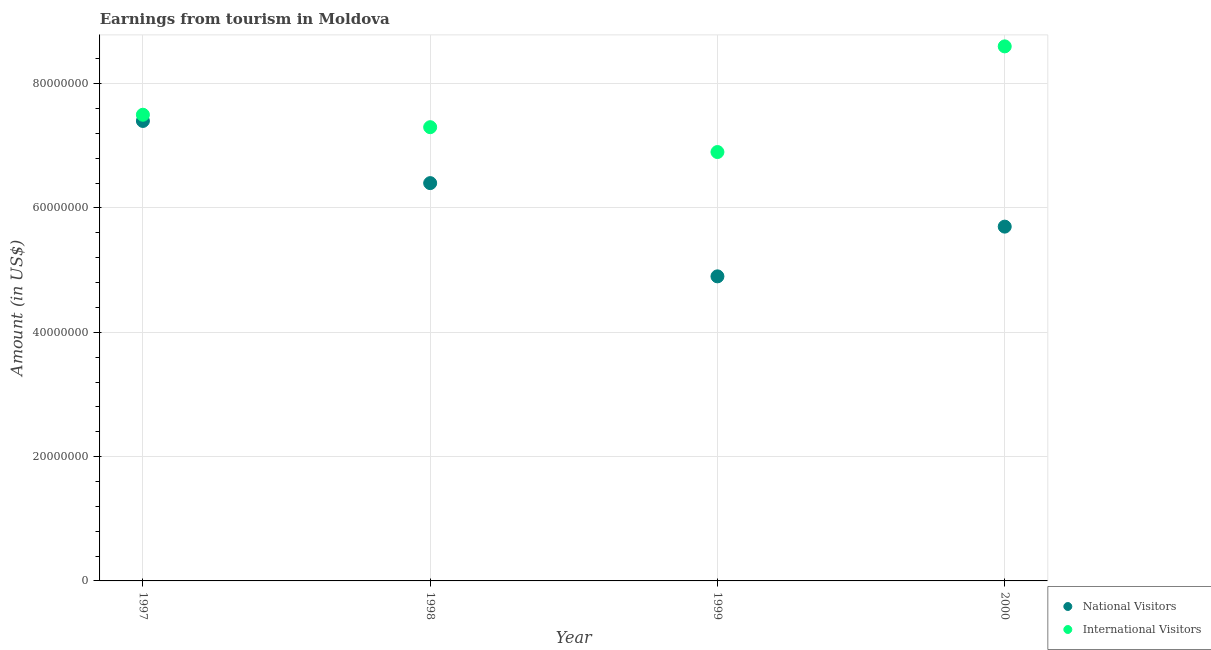What is the amount earned from international visitors in 1999?
Give a very brief answer. 6.90e+07. Across all years, what is the maximum amount earned from national visitors?
Make the answer very short. 7.40e+07. Across all years, what is the minimum amount earned from international visitors?
Your answer should be compact. 6.90e+07. What is the total amount earned from national visitors in the graph?
Make the answer very short. 2.44e+08. What is the difference between the amount earned from international visitors in 1998 and that in 1999?
Your answer should be compact. 4.00e+06. What is the difference between the amount earned from national visitors in 1997 and the amount earned from international visitors in 2000?
Offer a terse response. -1.20e+07. What is the average amount earned from national visitors per year?
Give a very brief answer. 6.10e+07. In the year 1999, what is the difference between the amount earned from international visitors and amount earned from national visitors?
Keep it short and to the point. 2.00e+07. In how many years, is the amount earned from national visitors greater than 80000000 US$?
Keep it short and to the point. 0. What is the ratio of the amount earned from international visitors in 1999 to that in 2000?
Make the answer very short. 0.8. What is the difference between the highest and the second highest amount earned from international visitors?
Offer a very short reply. 1.10e+07. What is the difference between the highest and the lowest amount earned from national visitors?
Offer a very short reply. 2.50e+07. Is the sum of the amount earned from national visitors in 1997 and 1998 greater than the maximum amount earned from international visitors across all years?
Keep it short and to the point. Yes. Does the amount earned from national visitors monotonically increase over the years?
Your answer should be very brief. No. Is the amount earned from national visitors strictly less than the amount earned from international visitors over the years?
Keep it short and to the point. Yes. How many dotlines are there?
Your response must be concise. 2. How many years are there in the graph?
Provide a succinct answer. 4. What is the difference between two consecutive major ticks on the Y-axis?
Make the answer very short. 2.00e+07. Are the values on the major ticks of Y-axis written in scientific E-notation?
Your answer should be very brief. No. Does the graph contain grids?
Provide a succinct answer. Yes. How many legend labels are there?
Offer a terse response. 2. What is the title of the graph?
Provide a short and direct response. Earnings from tourism in Moldova. Does "IMF nonconcessional" appear as one of the legend labels in the graph?
Keep it short and to the point. No. What is the label or title of the X-axis?
Your response must be concise. Year. What is the Amount (in US$) of National Visitors in 1997?
Keep it short and to the point. 7.40e+07. What is the Amount (in US$) of International Visitors in 1997?
Provide a short and direct response. 7.50e+07. What is the Amount (in US$) in National Visitors in 1998?
Provide a succinct answer. 6.40e+07. What is the Amount (in US$) of International Visitors in 1998?
Your response must be concise. 7.30e+07. What is the Amount (in US$) in National Visitors in 1999?
Ensure brevity in your answer.  4.90e+07. What is the Amount (in US$) in International Visitors in 1999?
Your answer should be compact. 6.90e+07. What is the Amount (in US$) in National Visitors in 2000?
Your answer should be very brief. 5.70e+07. What is the Amount (in US$) of International Visitors in 2000?
Offer a terse response. 8.60e+07. Across all years, what is the maximum Amount (in US$) in National Visitors?
Offer a terse response. 7.40e+07. Across all years, what is the maximum Amount (in US$) of International Visitors?
Provide a succinct answer. 8.60e+07. Across all years, what is the minimum Amount (in US$) in National Visitors?
Your answer should be compact. 4.90e+07. Across all years, what is the minimum Amount (in US$) in International Visitors?
Offer a very short reply. 6.90e+07. What is the total Amount (in US$) in National Visitors in the graph?
Offer a very short reply. 2.44e+08. What is the total Amount (in US$) of International Visitors in the graph?
Offer a very short reply. 3.03e+08. What is the difference between the Amount (in US$) in National Visitors in 1997 and that in 1998?
Offer a terse response. 1.00e+07. What is the difference between the Amount (in US$) in National Visitors in 1997 and that in 1999?
Provide a succinct answer. 2.50e+07. What is the difference between the Amount (in US$) of National Visitors in 1997 and that in 2000?
Make the answer very short. 1.70e+07. What is the difference between the Amount (in US$) of International Visitors in 1997 and that in 2000?
Offer a very short reply. -1.10e+07. What is the difference between the Amount (in US$) of National Visitors in 1998 and that in 1999?
Keep it short and to the point. 1.50e+07. What is the difference between the Amount (in US$) of International Visitors in 1998 and that in 1999?
Provide a succinct answer. 4.00e+06. What is the difference between the Amount (in US$) in International Visitors in 1998 and that in 2000?
Provide a succinct answer. -1.30e+07. What is the difference between the Amount (in US$) in National Visitors in 1999 and that in 2000?
Make the answer very short. -8.00e+06. What is the difference between the Amount (in US$) of International Visitors in 1999 and that in 2000?
Make the answer very short. -1.70e+07. What is the difference between the Amount (in US$) of National Visitors in 1997 and the Amount (in US$) of International Visitors in 1998?
Your answer should be compact. 1.00e+06. What is the difference between the Amount (in US$) in National Visitors in 1997 and the Amount (in US$) in International Visitors in 1999?
Make the answer very short. 5.00e+06. What is the difference between the Amount (in US$) in National Visitors in 1997 and the Amount (in US$) in International Visitors in 2000?
Give a very brief answer. -1.20e+07. What is the difference between the Amount (in US$) in National Visitors in 1998 and the Amount (in US$) in International Visitors in 1999?
Make the answer very short. -5.00e+06. What is the difference between the Amount (in US$) of National Visitors in 1998 and the Amount (in US$) of International Visitors in 2000?
Your answer should be very brief. -2.20e+07. What is the difference between the Amount (in US$) in National Visitors in 1999 and the Amount (in US$) in International Visitors in 2000?
Your answer should be very brief. -3.70e+07. What is the average Amount (in US$) of National Visitors per year?
Offer a very short reply. 6.10e+07. What is the average Amount (in US$) of International Visitors per year?
Provide a short and direct response. 7.58e+07. In the year 1998, what is the difference between the Amount (in US$) in National Visitors and Amount (in US$) in International Visitors?
Give a very brief answer. -9.00e+06. In the year 1999, what is the difference between the Amount (in US$) of National Visitors and Amount (in US$) of International Visitors?
Offer a terse response. -2.00e+07. In the year 2000, what is the difference between the Amount (in US$) of National Visitors and Amount (in US$) of International Visitors?
Your answer should be compact. -2.90e+07. What is the ratio of the Amount (in US$) of National Visitors in 1997 to that in 1998?
Give a very brief answer. 1.16. What is the ratio of the Amount (in US$) in International Visitors in 1997 to that in 1998?
Your answer should be very brief. 1.03. What is the ratio of the Amount (in US$) in National Visitors in 1997 to that in 1999?
Your answer should be very brief. 1.51. What is the ratio of the Amount (in US$) in International Visitors in 1997 to that in 1999?
Your answer should be compact. 1.09. What is the ratio of the Amount (in US$) in National Visitors in 1997 to that in 2000?
Provide a succinct answer. 1.3. What is the ratio of the Amount (in US$) of International Visitors in 1997 to that in 2000?
Offer a terse response. 0.87. What is the ratio of the Amount (in US$) in National Visitors in 1998 to that in 1999?
Your answer should be very brief. 1.31. What is the ratio of the Amount (in US$) of International Visitors in 1998 to that in 1999?
Provide a short and direct response. 1.06. What is the ratio of the Amount (in US$) in National Visitors in 1998 to that in 2000?
Keep it short and to the point. 1.12. What is the ratio of the Amount (in US$) in International Visitors in 1998 to that in 2000?
Your response must be concise. 0.85. What is the ratio of the Amount (in US$) of National Visitors in 1999 to that in 2000?
Your answer should be very brief. 0.86. What is the ratio of the Amount (in US$) of International Visitors in 1999 to that in 2000?
Ensure brevity in your answer.  0.8. What is the difference between the highest and the second highest Amount (in US$) of National Visitors?
Offer a very short reply. 1.00e+07. What is the difference between the highest and the second highest Amount (in US$) in International Visitors?
Your answer should be compact. 1.10e+07. What is the difference between the highest and the lowest Amount (in US$) of National Visitors?
Your answer should be compact. 2.50e+07. What is the difference between the highest and the lowest Amount (in US$) in International Visitors?
Give a very brief answer. 1.70e+07. 